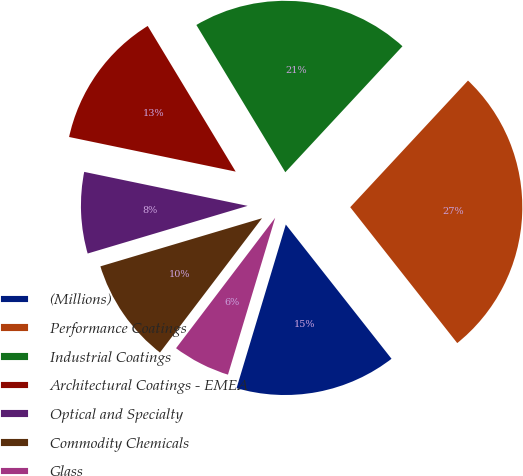Convert chart to OTSL. <chart><loc_0><loc_0><loc_500><loc_500><pie_chart><fcel>(Millions)<fcel>Performance Coatings<fcel>Industrial Coatings<fcel>Architectural Coatings - EMEA<fcel>Optical and Specialty<fcel>Commodity Chemicals<fcel>Glass<nl><fcel>15.27%<fcel>27.46%<fcel>20.57%<fcel>13.09%<fcel>7.87%<fcel>10.05%<fcel>5.69%<nl></chart> 